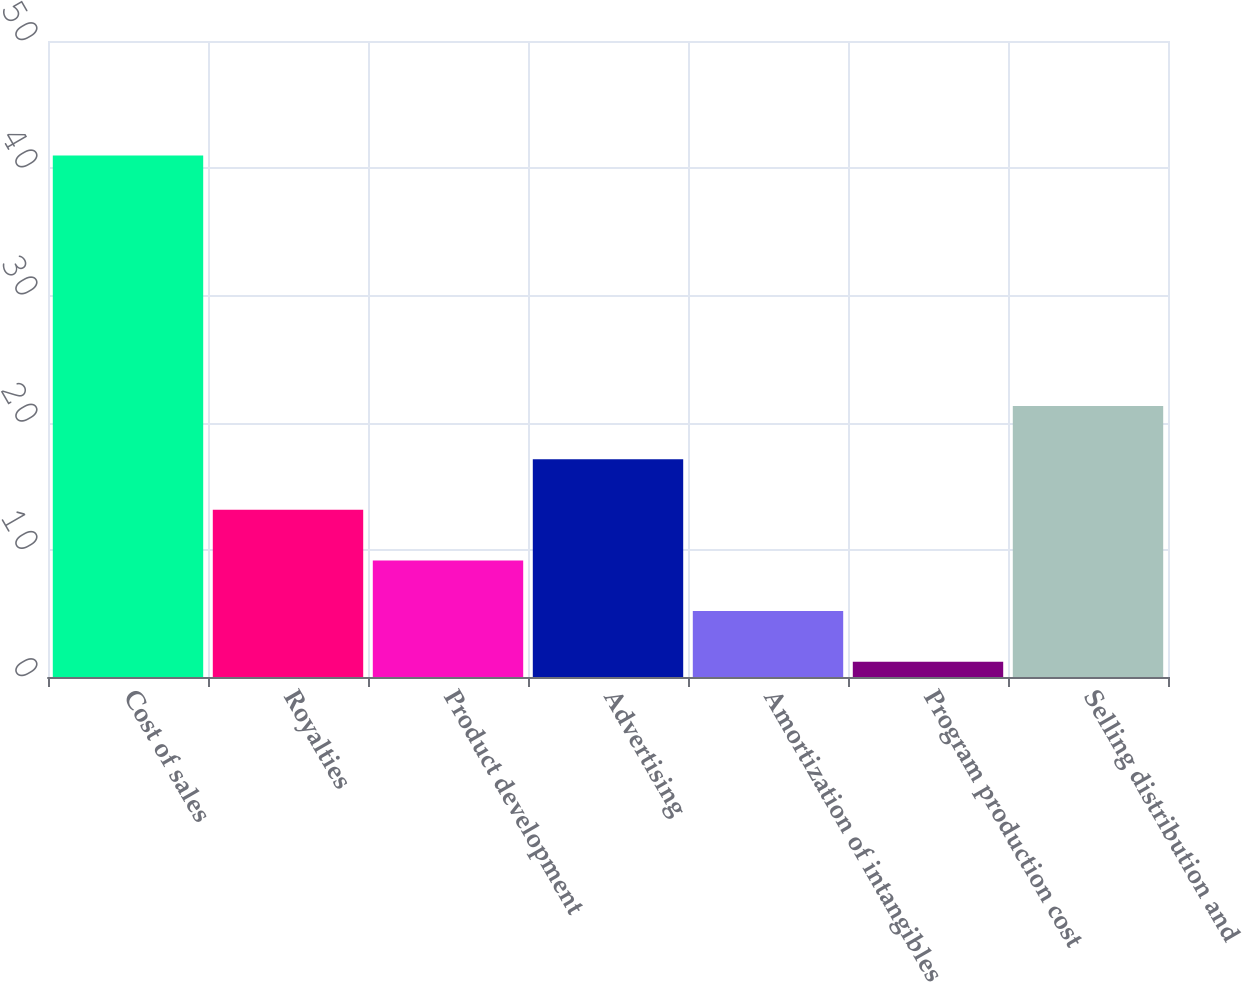<chart> <loc_0><loc_0><loc_500><loc_500><bar_chart><fcel>Cost of sales<fcel>Royalties<fcel>Product development<fcel>Advertising<fcel>Amortization of intangibles<fcel>Program production cost<fcel>Selling distribution and<nl><fcel>41<fcel>13.14<fcel>9.16<fcel>17.12<fcel>5.18<fcel>1.2<fcel>21.3<nl></chart> 